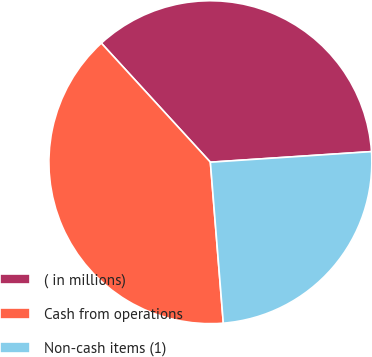Convert chart to OTSL. <chart><loc_0><loc_0><loc_500><loc_500><pie_chart><fcel>( in millions)<fcel>Cash from operations<fcel>Non-cash items (1)<nl><fcel>35.76%<fcel>39.48%<fcel>24.77%<nl></chart> 